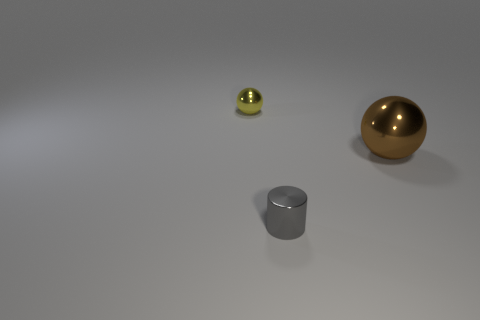There is a metallic sphere behind the brown shiny ball; does it have the same color as the large metal thing?
Your answer should be very brief. No. Do the yellow object and the brown thing have the same material?
Your answer should be very brief. Yes. Are there an equal number of small metallic objects that are to the left of the tiny gray cylinder and big brown shiny balls to the left of the large brown sphere?
Provide a succinct answer. No. There is a yellow object that is the same shape as the brown thing; what material is it?
Make the answer very short. Metal. What shape is the tiny object to the right of the metallic ball left of the small shiny thing in front of the small metallic sphere?
Make the answer very short. Cylinder. Is the number of gray things that are behind the yellow sphere greater than the number of small brown metal cylinders?
Make the answer very short. No. Do the tiny object behind the large brown ball and the tiny gray object have the same shape?
Your answer should be very brief. No. What is the material of the object that is to the left of the gray shiny object?
Offer a very short reply. Metal. What number of tiny metal things are the same shape as the big brown object?
Give a very brief answer. 1. There is a small thing on the right side of the thing that is behind the big brown thing; what is its material?
Offer a very short reply. Metal. 